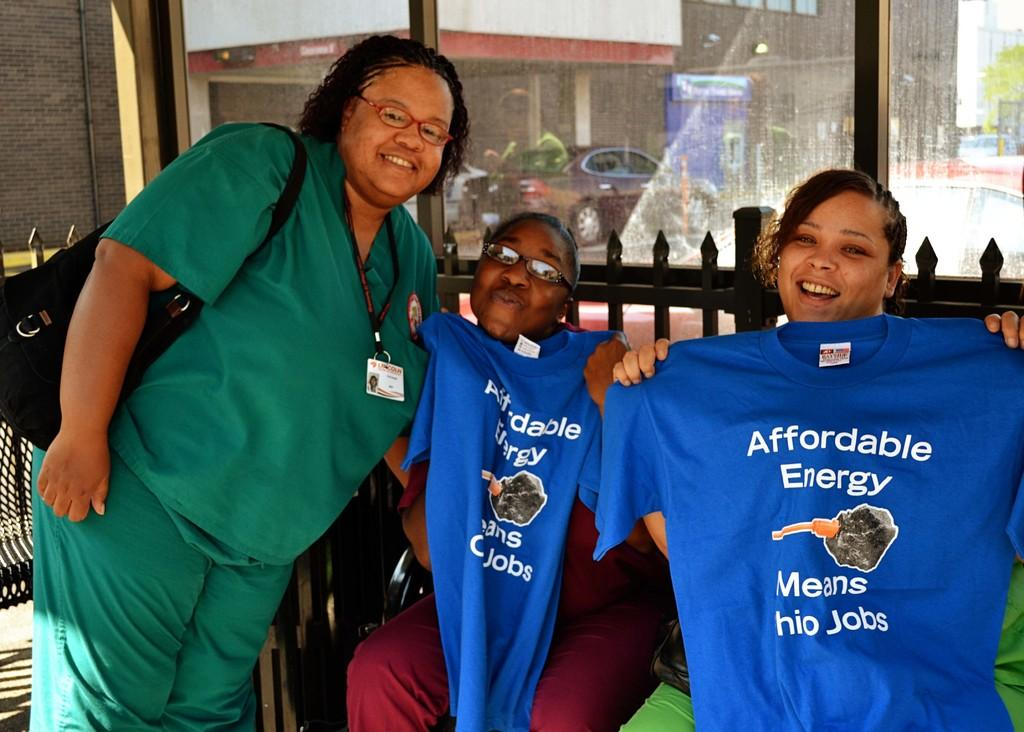Provide a one-sentence caption for the provided image. A group of women posing with T-shirts in support of affordable energy. 